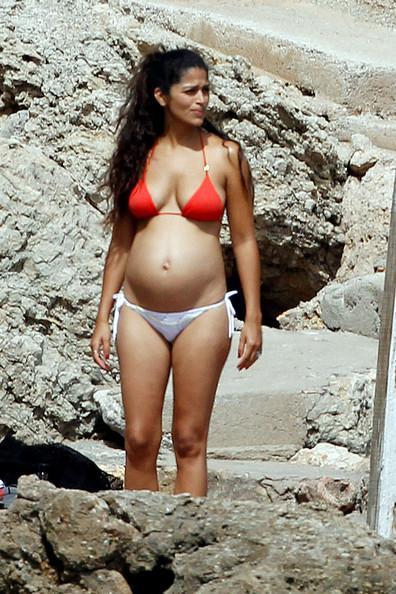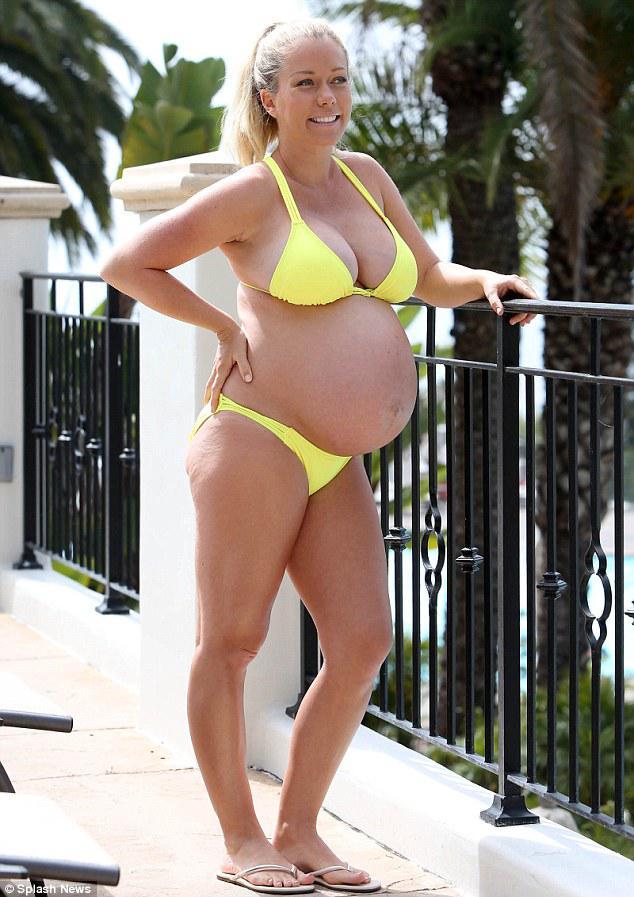The first image is the image on the left, the second image is the image on the right. Examine the images to the left and right. Is the description "There is a woman with at least one of her hands touching her hair." accurate? Answer yes or no. No. 